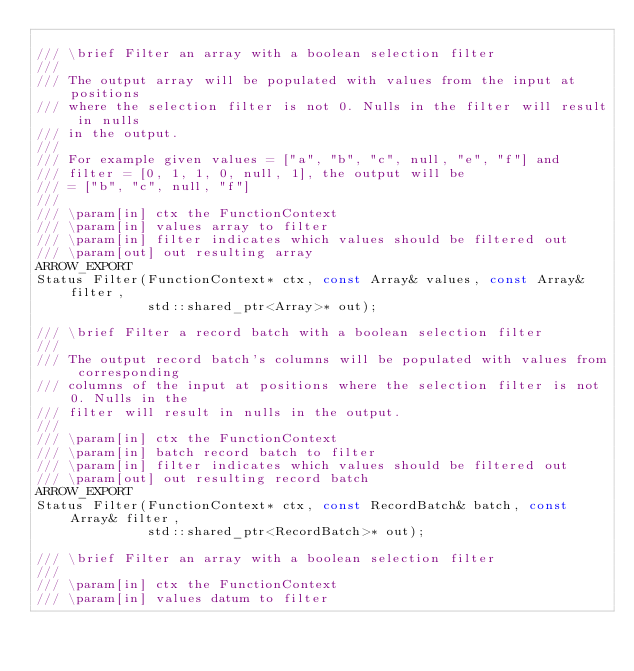Convert code to text. <code><loc_0><loc_0><loc_500><loc_500><_C_>
/// \brief Filter an array with a boolean selection filter
///
/// The output array will be populated with values from the input at positions
/// where the selection filter is not 0. Nulls in the filter will result in nulls
/// in the output.
///
/// For example given values = ["a", "b", "c", null, "e", "f"] and
/// filter = [0, 1, 1, 0, null, 1], the output will be
/// = ["b", "c", null, "f"]
///
/// \param[in] ctx the FunctionContext
/// \param[in] values array to filter
/// \param[in] filter indicates which values should be filtered out
/// \param[out] out resulting array
ARROW_EXPORT
Status Filter(FunctionContext* ctx, const Array& values, const Array& filter,
              std::shared_ptr<Array>* out);

/// \brief Filter a record batch with a boolean selection filter
///
/// The output record batch's columns will be populated with values from corresponding
/// columns of the input at positions where the selection filter is not 0. Nulls in the
/// filter will result in nulls in the output.
///
/// \param[in] ctx the FunctionContext
/// \param[in] batch record batch to filter
/// \param[in] filter indicates which values should be filtered out
/// \param[out] out resulting record batch
ARROW_EXPORT
Status Filter(FunctionContext* ctx, const RecordBatch& batch, const Array& filter,
              std::shared_ptr<RecordBatch>* out);

/// \brief Filter an array with a boolean selection filter
///
/// \param[in] ctx the FunctionContext
/// \param[in] values datum to filter</code> 